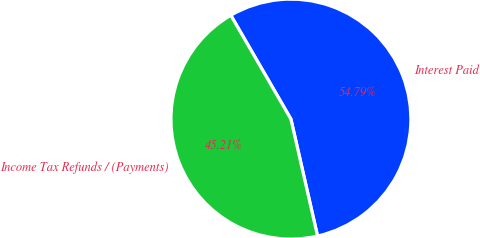Convert chart. <chart><loc_0><loc_0><loc_500><loc_500><pie_chart><fcel>Interest Paid<fcel>Income Tax Refunds / (Payments)<nl><fcel>54.79%<fcel>45.21%<nl></chart> 